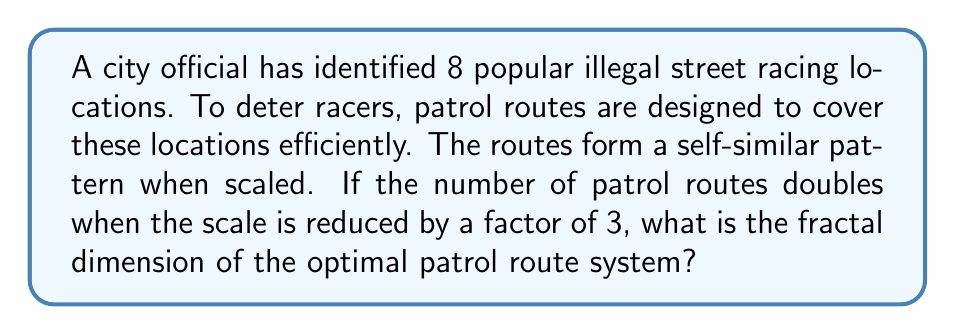Teach me how to tackle this problem. To determine the fractal dimension of the optimal patrol routes, we'll use the box-counting dimension formula:

$$D = \frac{\log N}{\log (1/r)}$$

Where:
- $D$ is the fractal dimension
- $N$ is the number of self-similar pieces
- $r$ is the scaling factor

Given:
1. The number of patrol routes doubles when the scale is reduced by a factor of 3.
2. This means $N = 2$ and $r = 1/3$

Step 1: Substitute the values into the formula:

$$D = \frac{\log 2}{\log (1/(1/3))} = \frac{\log 2}{\log 3}$$

Step 2: Calculate the logarithms:

$$D = \frac{0.6931...}{1.0986...}$$

Step 3: Divide to get the final result:

$$D \approx 0.6309$$

This fractal dimension indicates that the optimal patrol routes have a complexity between a one-dimensional line (D=1) and a two-dimensional plane (D=2), suggesting an efficient coverage of the area while maintaining a relatively simple structure.
Answer: $\frac{\log 2}{\log 3} \approx 0.6309$ 